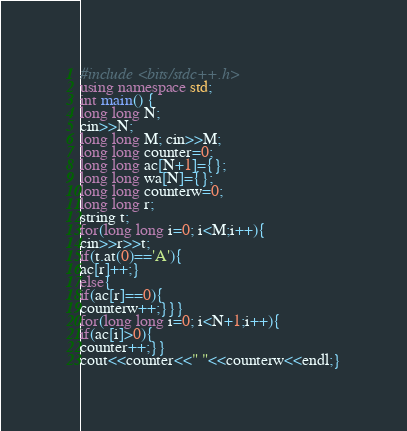<code> <loc_0><loc_0><loc_500><loc_500><_C++_>#include <bits/stdc++.h>
using namespace std;
int main() {
long long N;
cin>>N;
long long M; cin>>M;
long long counter=0;
long long ac[N+1]={};
long long wa[N]={};
long long counterw=0;
long long r;
string t;
for(long long i=0; i<M;i++){
cin>>r>>t;
if(t.at(0)=='A'){
ac[r]++;}
else{
if(ac[r]==0){
counterw++;}}}
for(long long i=0; i<N+1;i++){
if(ac[i]>0){
counter++;}}
cout<<counter<<" "<<counterw<<endl;}
</code> 